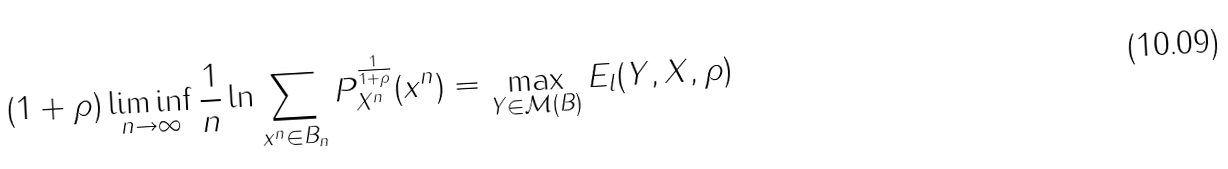Convert formula to latex. <formula><loc_0><loc_0><loc_500><loc_500>( 1 + \rho ) \liminf _ { n \rightarrow \infty } \frac { 1 } { n } \ln \sum _ { x ^ { n } \in B _ { n } } P _ { X ^ { n } } ^ { \frac { 1 } { 1 + \rho } } ( x ^ { n } ) = \max _ { Y \in \mathcal { M } ( B ) } E _ { l } ( Y , X , \rho )</formula> 